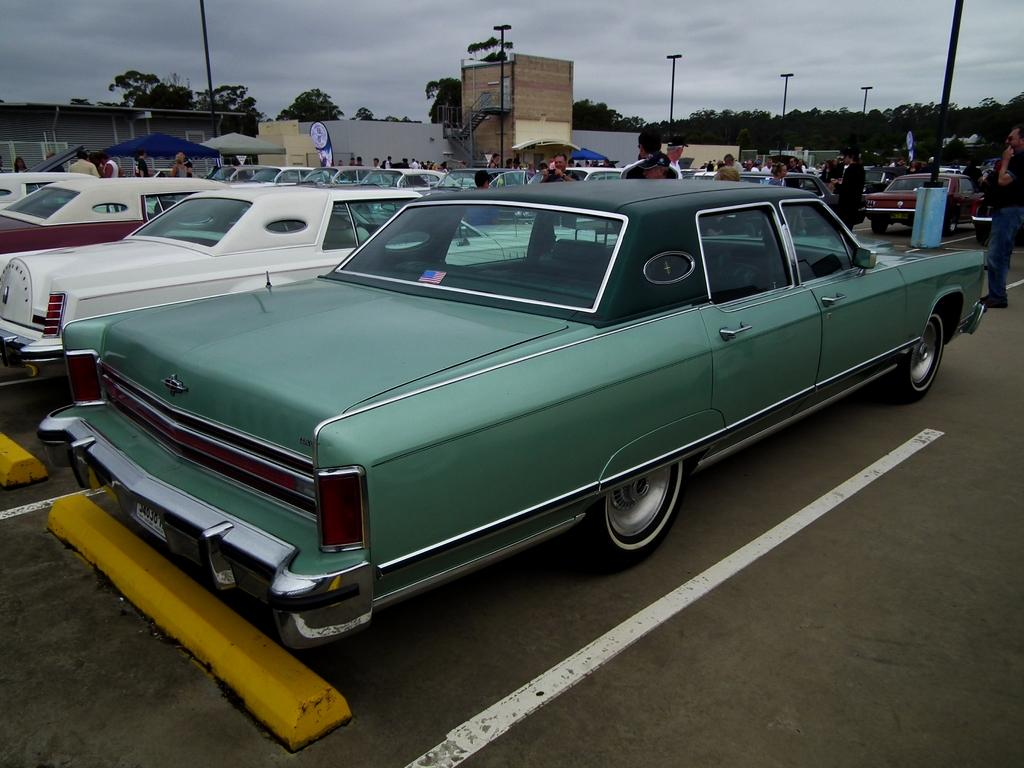What is happening on the road in the image? There are vehicles on the road in the image. Can you describe the people visible in the image? There are people visible in the image. What is located in the background of the image? There is a building and trees in the background of the image. What can be seen in the sky in the image? Clouds are visible in the sky in the image. What type of action is the chicken performing in the image? There is no chicken present in the image, so it is not possible to answer that question. 